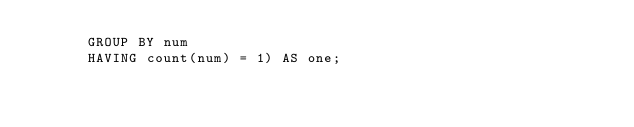<code> <loc_0><loc_0><loc_500><loc_500><_SQL_>      GROUP BY num
      HAVING count(num) = 1) AS one;
</code> 